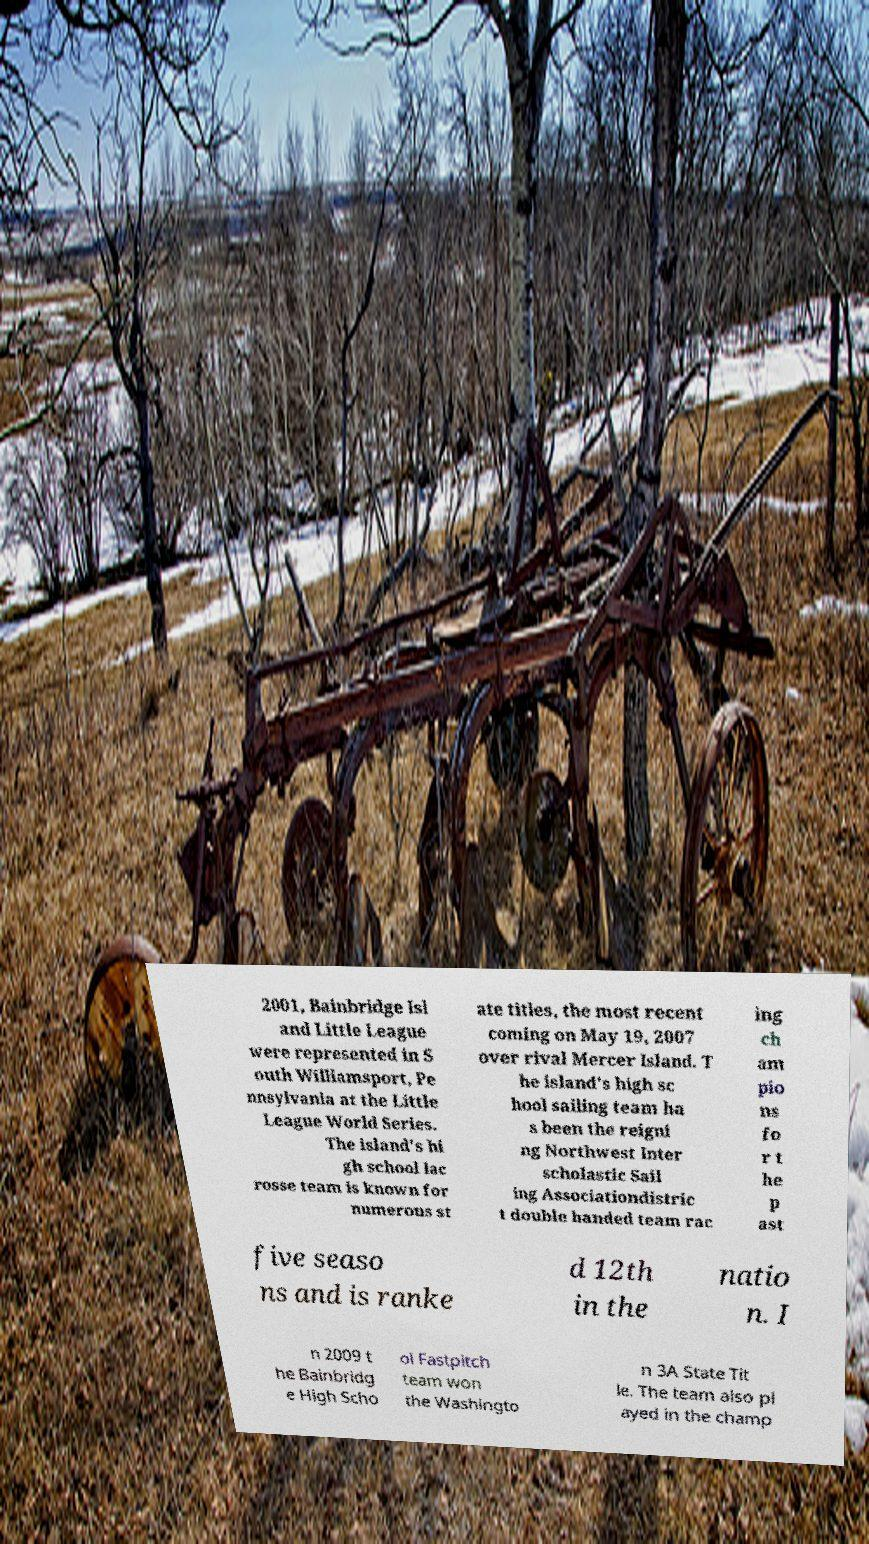What messages or text are displayed in this image? I need them in a readable, typed format. 2001, Bainbridge Isl and Little League were represented in S outh Williamsport, Pe nnsylvania at the Little League World Series. The island's hi gh school lac rosse team is known for numerous st ate titles, the most recent coming on May 19, 2007 over rival Mercer Island. T he island's high sc hool sailing team ha s been the reigni ng Northwest Inter scholastic Sail ing Associationdistric t double handed team rac ing ch am pio ns fo r t he p ast five seaso ns and is ranke d 12th in the natio n. I n 2009 t he Bainbridg e High Scho ol Fastpitch team won the Washingto n 3A State Tit le. The team also pl ayed in the champ 